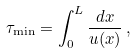Convert formula to latex. <formula><loc_0><loc_0><loc_500><loc_500>\tau _ { \min } = \int _ { 0 } ^ { L } \frac { d x } { u ( x ) } \, ,</formula> 